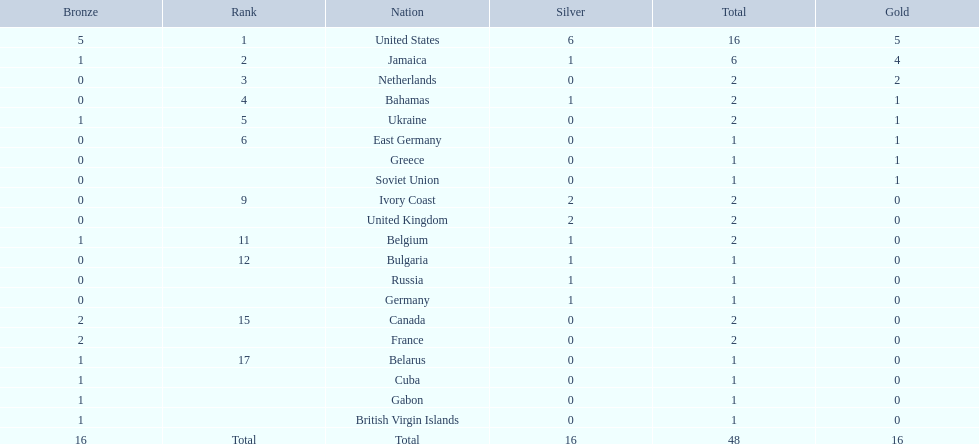Which nations secured a minimum of 3 silver medals? United States. 